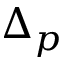Convert formula to latex. <formula><loc_0><loc_0><loc_500><loc_500>\Delta _ { p }</formula> 